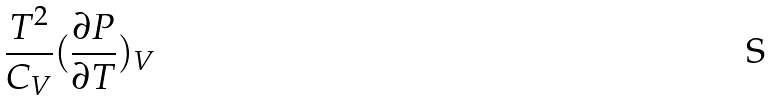<formula> <loc_0><loc_0><loc_500><loc_500>\frac { T ^ { 2 } } { C _ { V } } ( \frac { \partial P } { \partial T } ) _ { V }</formula> 